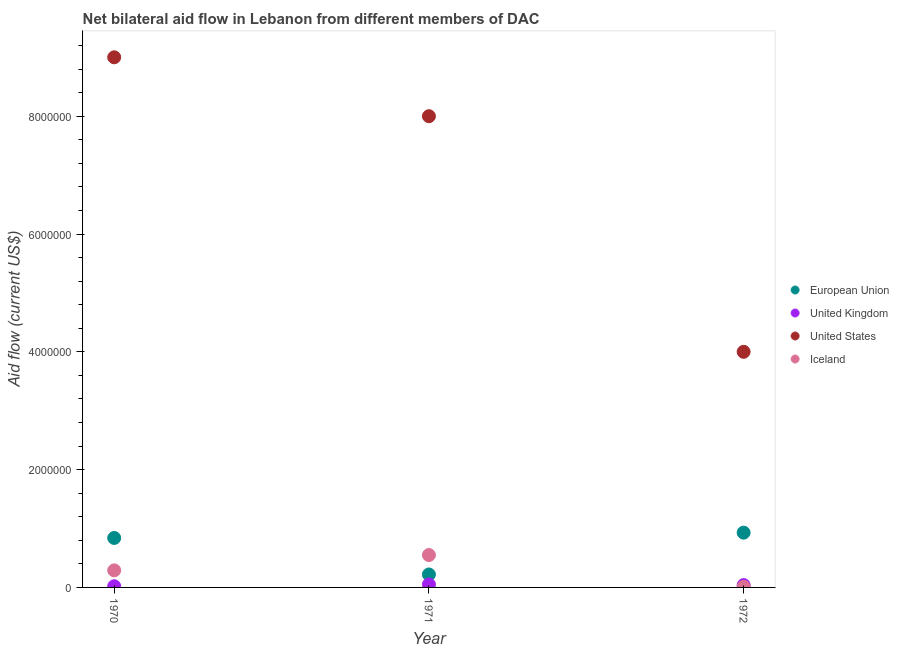How many different coloured dotlines are there?
Your answer should be compact. 4. Is the number of dotlines equal to the number of legend labels?
Your answer should be compact. Yes. What is the amount of aid given by eu in 1972?
Make the answer very short. 9.30e+05. Across all years, what is the maximum amount of aid given by eu?
Keep it short and to the point. 9.30e+05. Across all years, what is the minimum amount of aid given by eu?
Your answer should be compact. 2.20e+05. In which year was the amount of aid given by us maximum?
Ensure brevity in your answer.  1970. In which year was the amount of aid given by iceland minimum?
Keep it short and to the point. 1972. What is the total amount of aid given by iceland in the graph?
Provide a short and direct response. 8.50e+05. What is the difference between the amount of aid given by iceland in 1970 and that in 1971?
Offer a very short reply. -2.60e+05. What is the difference between the amount of aid given by eu in 1970 and the amount of aid given by iceland in 1971?
Provide a short and direct response. 2.90e+05. What is the average amount of aid given by iceland per year?
Provide a short and direct response. 2.83e+05. In the year 1972, what is the difference between the amount of aid given by uk and amount of aid given by iceland?
Your answer should be very brief. 3.00e+04. In how many years, is the amount of aid given by uk greater than 800000 US$?
Give a very brief answer. 0. What is the ratio of the amount of aid given by uk in 1970 to that in 1971?
Your response must be concise. 0.4. Is the difference between the amount of aid given by iceland in 1970 and 1972 greater than the difference between the amount of aid given by us in 1970 and 1972?
Your answer should be compact. No. What is the difference between the highest and the lowest amount of aid given by uk?
Provide a short and direct response. 3.00e+04. In how many years, is the amount of aid given by uk greater than the average amount of aid given by uk taken over all years?
Make the answer very short. 2. Is it the case that in every year, the sum of the amount of aid given by eu and amount of aid given by uk is greater than the sum of amount of aid given by us and amount of aid given by iceland?
Give a very brief answer. No. Is it the case that in every year, the sum of the amount of aid given by eu and amount of aid given by uk is greater than the amount of aid given by us?
Your answer should be compact. No. How many dotlines are there?
Your response must be concise. 4. How many years are there in the graph?
Give a very brief answer. 3. Does the graph contain grids?
Give a very brief answer. No. What is the title of the graph?
Make the answer very short. Net bilateral aid flow in Lebanon from different members of DAC. Does "Trade" appear as one of the legend labels in the graph?
Your response must be concise. No. What is the label or title of the X-axis?
Offer a terse response. Year. What is the Aid flow (current US$) in European Union in 1970?
Your answer should be very brief. 8.40e+05. What is the Aid flow (current US$) of United Kingdom in 1970?
Offer a terse response. 2.00e+04. What is the Aid flow (current US$) of United States in 1970?
Your response must be concise. 9.00e+06. What is the Aid flow (current US$) in European Union in 1971?
Ensure brevity in your answer.  2.20e+05. What is the Aid flow (current US$) of United States in 1971?
Give a very brief answer. 8.00e+06. What is the Aid flow (current US$) in Iceland in 1971?
Provide a succinct answer. 5.50e+05. What is the Aid flow (current US$) of European Union in 1972?
Provide a short and direct response. 9.30e+05. What is the Aid flow (current US$) of United States in 1972?
Your answer should be very brief. 4.00e+06. Across all years, what is the maximum Aid flow (current US$) in European Union?
Provide a short and direct response. 9.30e+05. Across all years, what is the maximum Aid flow (current US$) of United States?
Ensure brevity in your answer.  9.00e+06. Across all years, what is the maximum Aid flow (current US$) of Iceland?
Ensure brevity in your answer.  5.50e+05. Across all years, what is the minimum Aid flow (current US$) in European Union?
Provide a succinct answer. 2.20e+05. Across all years, what is the minimum Aid flow (current US$) in Iceland?
Offer a terse response. 10000. What is the total Aid flow (current US$) of European Union in the graph?
Offer a terse response. 1.99e+06. What is the total Aid flow (current US$) of United Kingdom in the graph?
Provide a succinct answer. 1.10e+05. What is the total Aid flow (current US$) in United States in the graph?
Your answer should be compact. 2.10e+07. What is the total Aid flow (current US$) of Iceland in the graph?
Your answer should be compact. 8.50e+05. What is the difference between the Aid flow (current US$) in European Union in 1970 and that in 1971?
Offer a terse response. 6.20e+05. What is the difference between the Aid flow (current US$) in Iceland in 1970 and that in 1971?
Your answer should be very brief. -2.60e+05. What is the difference between the Aid flow (current US$) of European Union in 1970 and that in 1972?
Provide a succinct answer. -9.00e+04. What is the difference between the Aid flow (current US$) of United Kingdom in 1970 and that in 1972?
Provide a succinct answer. -2.00e+04. What is the difference between the Aid flow (current US$) in United States in 1970 and that in 1972?
Keep it short and to the point. 5.00e+06. What is the difference between the Aid flow (current US$) in Iceland in 1970 and that in 1972?
Provide a succinct answer. 2.80e+05. What is the difference between the Aid flow (current US$) in European Union in 1971 and that in 1972?
Ensure brevity in your answer.  -7.10e+05. What is the difference between the Aid flow (current US$) in Iceland in 1971 and that in 1972?
Offer a terse response. 5.40e+05. What is the difference between the Aid flow (current US$) in European Union in 1970 and the Aid flow (current US$) in United Kingdom in 1971?
Make the answer very short. 7.90e+05. What is the difference between the Aid flow (current US$) in European Union in 1970 and the Aid flow (current US$) in United States in 1971?
Offer a very short reply. -7.16e+06. What is the difference between the Aid flow (current US$) in United Kingdom in 1970 and the Aid flow (current US$) in United States in 1971?
Your answer should be very brief. -7.98e+06. What is the difference between the Aid flow (current US$) in United Kingdom in 1970 and the Aid flow (current US$) in Iceland in 1971?
Your response must be concise. -5.30e+05. What is the difference between the Aid flow (current US$) in United States in 1970 and the Aid flow (current US$) in Iceland in 1971?
Your response must be concise. 8.45e+06. What is the difference between the Aid flow (current US$) in European Union in 1970 and the Aid flow (current US$) in United States in 1972?
Provide a short and direct response. -3.16e+06. What is the difference between the Aid flow (current US$) of European Union in 1970 and the Aid flow (current US$) of Iceland in 1972?
Your answer should be compact. 8.30e+05. What is the difference between the Aid flow (current US$) in United Kingdom in 1970 and the Aid flow (current US$) in United States in 1972?
Your response must be concise. -3.98e+06. What is the difference between the Aid flow (current US$) of United States in 1970 and the Aid flow (current US$) of Iceland in 1972?
Your answer should be compact. 8.99e+06. What is the difference between the Aid flow (current US$) of European Union in 1971 and the Aid flow (current US$) of United States in 1972?
Your response must be concise. -3.78e+06. What is the difference between the Aid flow (current US$) of European Union in 1971 and the Aid flow (current US$) of Iceland in 1972?
Offer a terse response. 2.10e+05. What is the difference between the Aid flow (current US$) in United Kingdom in 1971 and the Aid flow (current US$) in United States in 1972?
Provide a short and direct response. -3.95e+06. What is the difference between the Aid flow (current US$) in United States in 1971 and the Aid flow (current US$) in Iceland in 1972?
Offer a terse response. 7.99e+06. What is the average Aid flow (current US$) in European Union per year?
Your answer should be very brief. 6.63e+05. What is the average Aid flow (current US$) of United Kingdom per year?
Keep it short and to the point. 3.67e+04. What is the average Aid flow (current US$) of United States per year?
Provide a succinct answer. 7.00e+06. What is the average Aid flow (current US$) of Iceland per year?
Make the answer very short. 2.83e+05. In the year 1970, what is the difference between the Aid flow (current US$) in European Union and Aid flow (current US$) in United Kingdom?
Provide a short and direct response. 8.20e+05. In the year 1970, what is the difference between the Aid flow (current US$) in European Union and Aid flow (current US$) in United States?
Ensure brevity in your answer.  -8.16e+06. In the year 1970, what is the difference between the Aid flow (current US$) in European Union and Aid flow (current US$) in Iceland?
Keep it short and to the point. 5.50e+05. In the year 1970, what is the difference between the Aid flow (current US$) in United Kingdom and Aid flow (current US$) in United States?
Offer a terse response. -8.98e+06. In the year 1970, what is the difference between the Aid flow (current US$) of United States and Aid flow (current US$) of Iceland?
Give a very brief answer. 8.71e+06. In the year 1971, what is the difference between the Aid flow (current US$) in European Union and Aid flow (current US$) in United States?
Your answer should be compact. -7.78e+06. In the year 1971, what is the difference between the Aid flow (current US$) in European Union and Aid flow (current US$) in Iceland?
Provide a short and direct response. -3.30e+05. In the year 1971, what is the difference between the Aid flow (current US$) of United Kingdom and Aid flow (current US$) of United States?
Ensure brevity in your answer.  -7.95e+06. In the year 1971, what is the difference between the Aid flow (current US$) in United Kingdom and Aid flow (current US$) in Iceland?
Ensure brevity in your answer.  -5.00e+05. In the year 1971, what is the difference between the Aid flow (current US$) of United States and Aid flow (current US$) of Iceland?
Give a very brief answer. 7.45e+06. In the year 1972, what is the difference between the Aid flow (current US$) in European Union and Aid flow (current US$) in United Kingdom?
Your response must be concise. 8.90e+05. In the year 1972, what is the difference between the Aid flow (current US$) of European Union and Aid flow (current US$) of United States?
Offer a very short reply. -3.07e+06. In the year 1972, what is the difference between the Aid flow (current US$) in European Union and Aid flow (current US$) in Iceland?
Keep it short and to the point. 9.20e+05. In the year 1972, what is the difference between the Aid flow (current US$) of United Kingdom and Aid flow (current US$) of United States?
Keep it short and to the point. -3.96e+06. In the year 1972, what is the difference between the Aid flow (current US$) of United Kingdom and Aid flow (current US$) of Iceland?
Your answer should be compact. 3.00e+04. In the year 1972, what is the difference between the Aid flow (current US$) of United States and Aid flow (current US$) of Iceland?
Offer a terse response. 3.99e+06. What is the ratio of the Aid flow (current US$) in European Union in 1970 to that in 1971?
Provide a short and direct response. 3.82. What is the ratio of the Aid flow (current US$) of United Kingdom in 1970 to that in 1971?
Your answer should be very brief. 0.4. What is the ratio of the Aid flow (current US$) in United States in 1970 to that in 1971?
Make the answer very short. 1.12. What is the ratio of the Aid flow (current US$) of Iceland in 1970 to that in 1971?
Ensure brevity in your answer.  0.53. What is the ratio of the Aid flow (current US$) in European Union in 1970 to that in 1972?
Your response must be concise. 0.9. What is the ratio of the Aid flow (current US$) in United Kingdom in 1970 to that in 1972?
Provide a short and direct response. 0.5. What is the ratio of the Aid flow (current US$) of United States in 1970 to that in 1972?
Offer a very short reply. 2.25. What is the ratio of the Aid flow (current US$) of Iceland in 1970 to that in 1972?
Ensure brevity in your answer.  29. What is the ratio of the Aid flow (current US$) in European Union in 1971 to that in 1972?
Provide a short and direct response. 0.24. What is the ratio of the Aid flow (current US$) in Iceland in 1971 to that in 1972?
Your response must be concise. 55. What is the difference between the highest and the second highest Aid flow (current US$) in European Union?
Your response must be concise. 9.00e+04. What is the difference between the highest and the second highest Aid flow (current US$) in United Kingdom?
Offer a terse response. 10000. What is the difference between the highest and the second highest Aid flow (current US$) of United States?
Offer a terse response. 1.00e+06. What is the difference between the highest and the second highest Aid flow (current US$) of Iceland?
Keep it short and to the point. 2.60e+05. What is the difference between the highest and the lowest Aid flow (current US$) of European Union?
Provide a short and direct response. 7.10e+05. What is the difference between the highest and the lowest Aid flow (current US$) in United Kingdom?
Give a very brief answer. 3.00e+04. What is the difference between the highest and the lowest Aid flow (current US$) in Iceland?
Make the answer very short. 5.40e+05. 